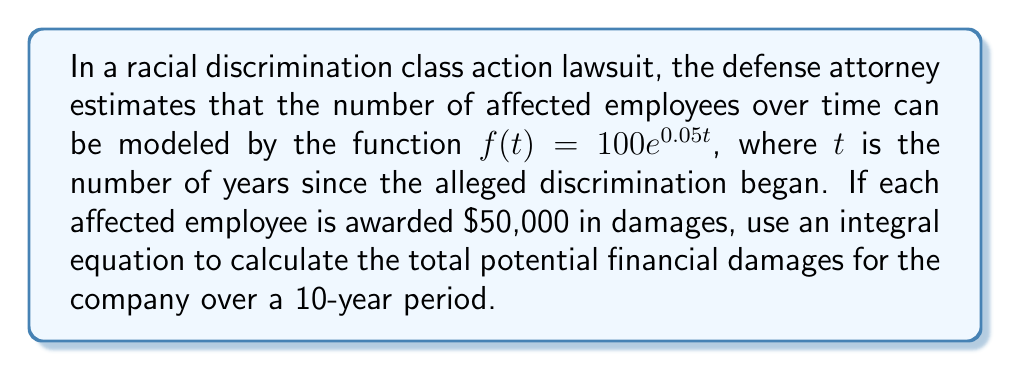Provide a solution to this math problem. To solve this problem, we need to follow these steps:

1) The function $f(t) = 100e^{0.05t}$ represents the number of affected employees at time $t$.

2) To find the total number of affected employees over the 10-year period, we need to integrate this function from $t=0$ to $t=10$.

3) Each employee is awarded $50,000, so we need to multiply our integral by 50,000.

4) Our integral equation for total damages $D$ is:

   $$D = 50000 \int_0^{10} 100e^{0.05t} dt$$

5) Simplify the constant:

   $$D = 5000000 \int_0^{10} e^{0.05t} dt$$

6) To integrate $e^{0.05t}$, we use the formula $\int e^{ax} dx = \frac{1}{a}e^{ax} + C$

7) Applying this:

   $$D = 5000000 [\frac{1}{0.05}e^{0.05t}]_0^{10}$$

8) Evaluate the integral:

   $$D = 5000000 [\frac{1}{0.05}e^{0.05(10)} - \frac{1}{0.05}e^{0.05(0)}]$$

9) Simplify:

   $$D = 5000000 [\frac{1}{0.05}(e^{0.5} - 1)]$$
   $$D = 100000000 (e^{0.5} - 1)$$

10) Calculate the final value:

    $$D \approx 164,872,127.07$$
Answer: $164,872,127.07 